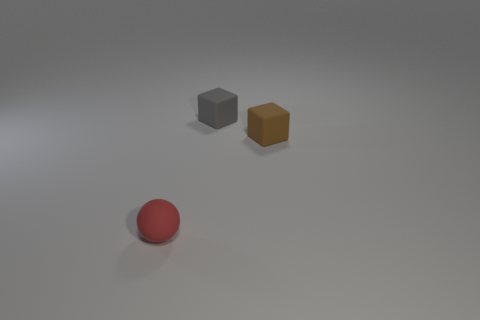How big is the brown cube?
Keep it short and to the point. Small. Is there a thing that has the same material as the sphere?
Provide a succinct answer. Yes. The other object that is the same shape as the small gray rubber object is what size?
Your answer should be very brief. Small. Are there an equal number of small red matte balls that are in front of the small red thing and tiny yellow spheres?
Provide a succinct answer. Yes. There is a object that is to the left of the gray matte cube; is it the same shape as the tiny brown object?
Keep it short and to the point. No. The small gray thing is what shape?
Provide a short and direct response. Cube. The cube that is on the right side of the block that is to the left of the small block that is in front of the gray matte thing is made of what material?
Make the answer very short. Rubber. How many things are either tiny green cubes or small rubber blocks?
Offer a very short reply. 2. Are the small object behind the brown rubber object and the red object made of the same material?
Offer a terse response. Yes. How many objects are things to the left of the brown thing or red matte things?
Your answer should be compact. 2. 